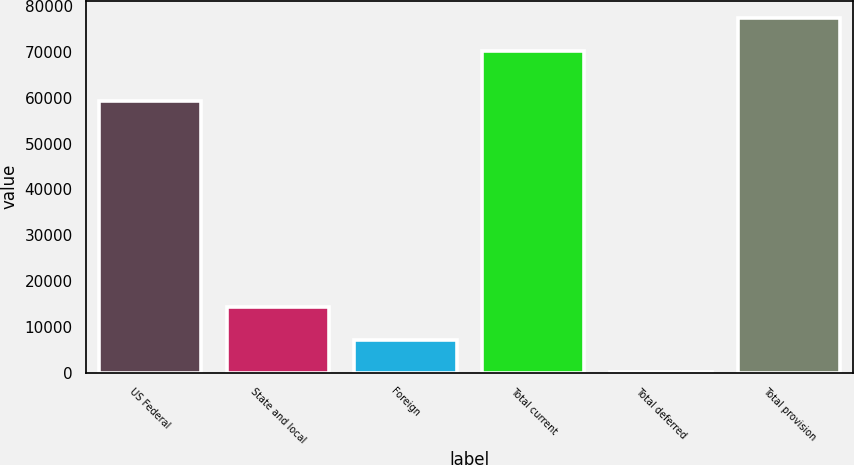<chart> <loc_0><loc_0><loc_500><loc_500><bar_chart><fcel>US Federal<fcel>State and local<fcel>Foreign<fcel>Total current<fcel>Total deferred<fcel>Total provision<nl><fcel>59254<fcel>14282.8<fcel>7254.4<fcel>70284<fcel>226<fcel>77312.4<nl></chart> 